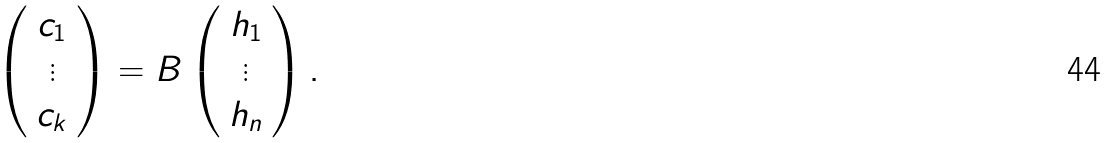<formula> <loc_0><loc_0><loc_500><loc_500>\left ( \begin{array} { c } c _ { 1 } \\ \vdots \\ c _ { k } \end{array} \right ) = B \left ( \begin{array} { c } h _ { 1 } \\ \vdots \\ h _ { n } \end{array} \right ) .</formula> 